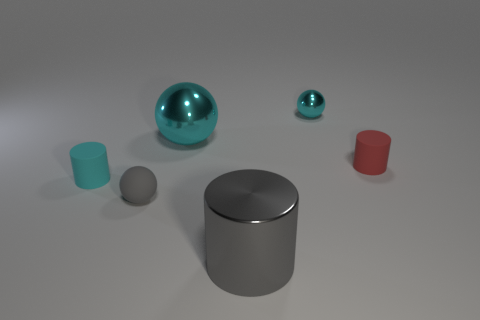Subtract all cyan shiny balls. How many balls are left? 1 Subtract all cyan cylinders. How many cylinders are left? 2 Add 1 big cyan metal things. How many objects exist? 7 Subtract 3 cylinders. How many cylinders are left? 0 Subtract all yellow balls. Subtract all blue cubes. How many balls are left? 3 Subtract all cyan balls. How many brown cylinders are left? 0 Subtract all red cylinders. Subtract all tiny cylinders. How many objects are left? 3 Add 4 red matte objects. How many red matte objects are left? 5 Add 1 purple shiny things. How many purple shiny things exist? 1 Subtract 0 green balls. How many objects are left? 6 